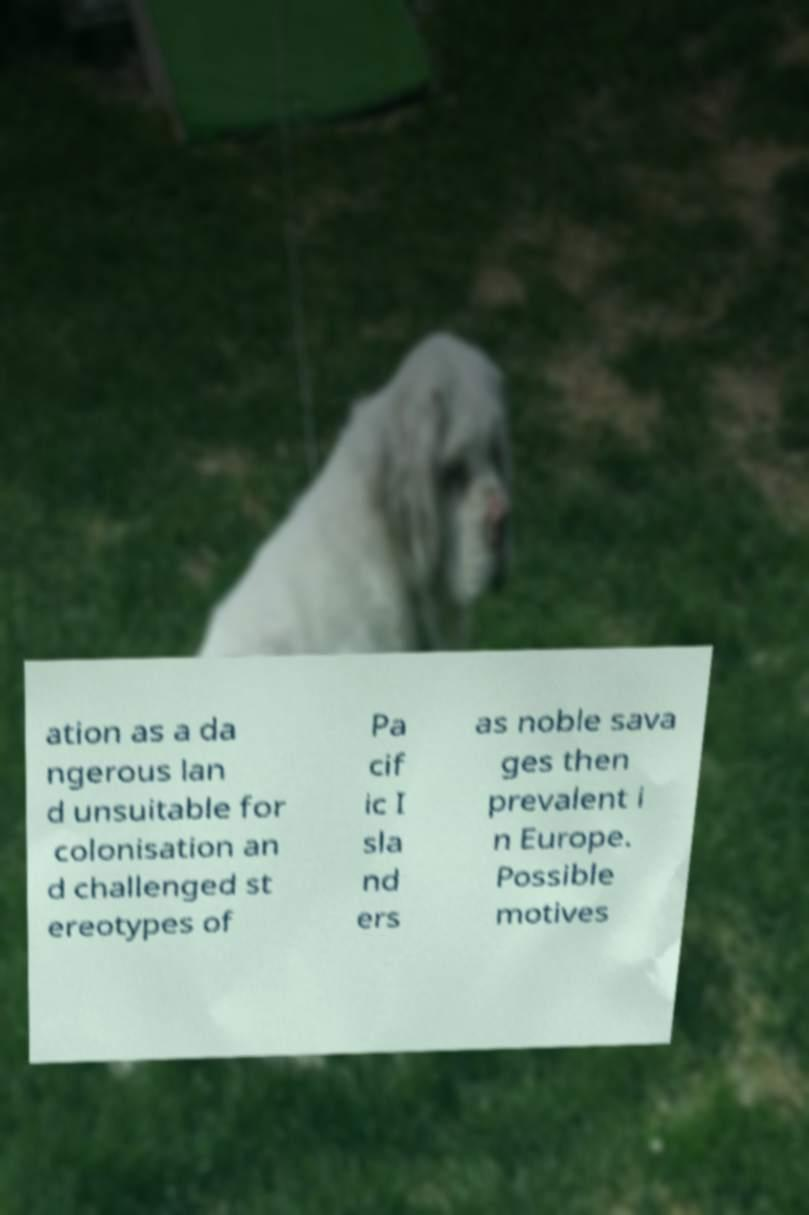What messages or text are displayed in this image? I need them in a readable, typed format. ation as a da ngerous lan d unsuitable for colonisation an d challenged st ereotypes of Pa cif ic I sla nd ers as noble sava ges then prevalent i n Europe. Possible motives 